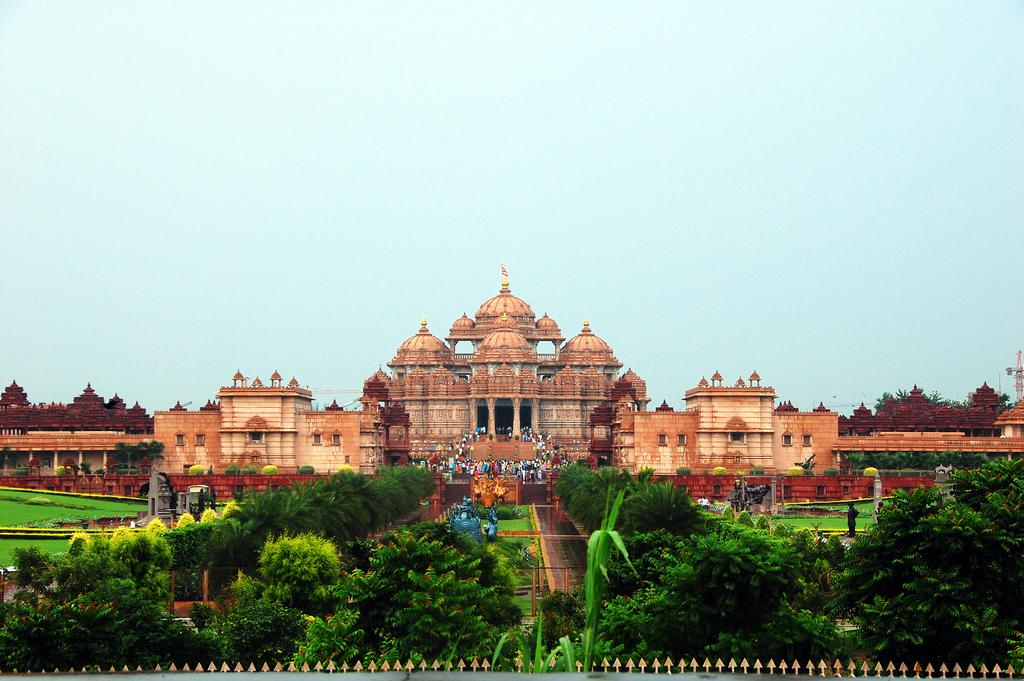What type of structure is present in the image? There is a temple in the image. Are there any living beings in the image? Yes, there are people in the image. What type of vegetation can be seen in the image? There are trees and grass in the image. What is visible in the background of the image? The sky is visible in the background of the image. Can you hear the kettle boiling in the image? There is no kettle present in the image, so it cannot be heard boiling. 